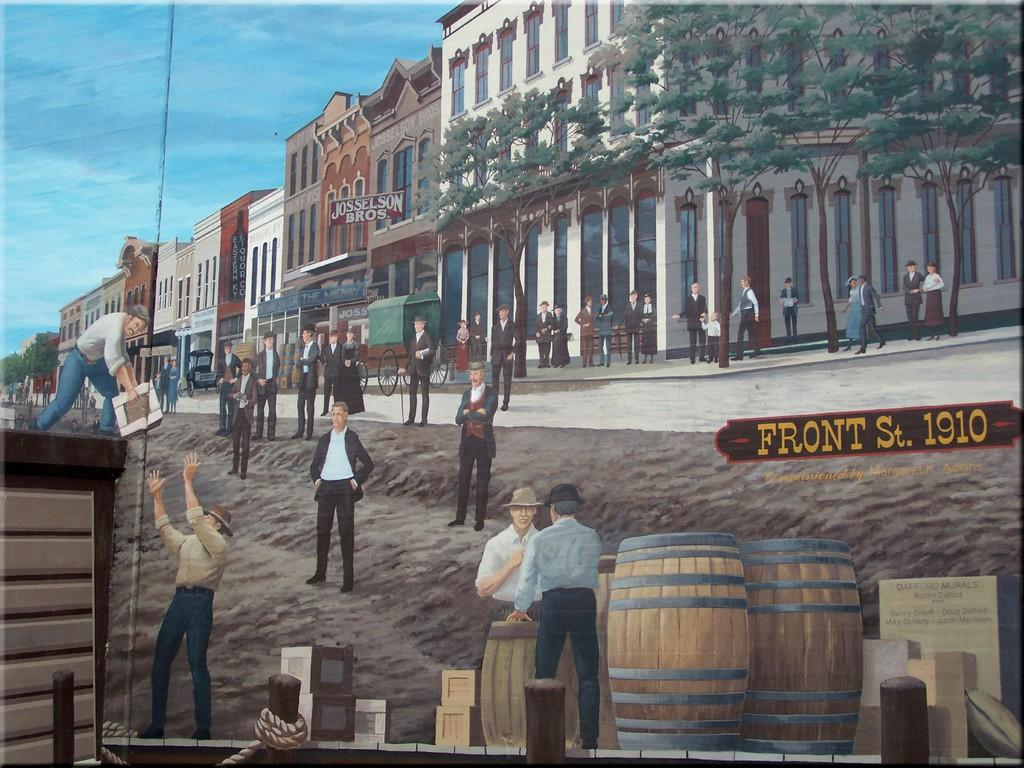<image>
Offer a succinct explanation of the picture presented. A colorful illustration shows life on Front Street in 1910. 